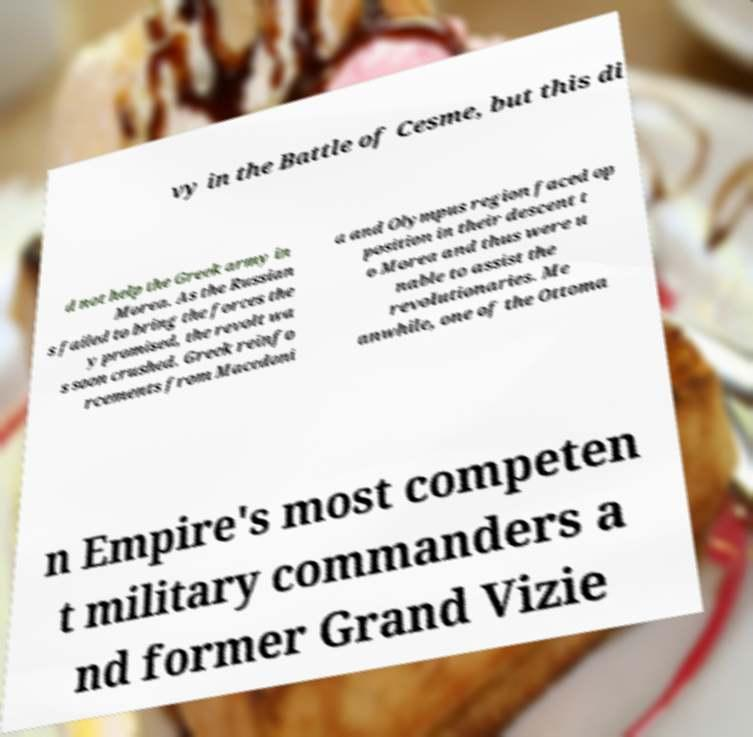There's text embedded in this image that I need extracted. Can you transcribe it verbatim? vy in the Battle of Cesme, but this di d not help the Greek army in Morea. As the Russian s failed to bring the forces the y promised, the revolt wa s soon crushed. Greek reinfo rcements from Macedoni a and Olympus region faced op position in their descent t o Morea and thus were u nable to assist the revolutionaries. Me anwhile, one of the Ottoma n Empire's most competen t military commanders a nd former Grand Vizie 